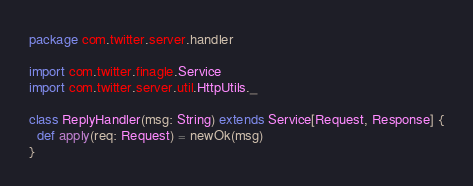Convert code to text. <code><loc_0><loc_0><loc_500><loc_500><_Scala_>package com.twitter.server.handler

import com.twitter.finagle.Service
import com.twitter.server.util.HttpUtils._

class ReplyHandler(msg: String) extends Service[Request, Response] {
  def apply(req: Request) = newOk(msg)
}</code> 